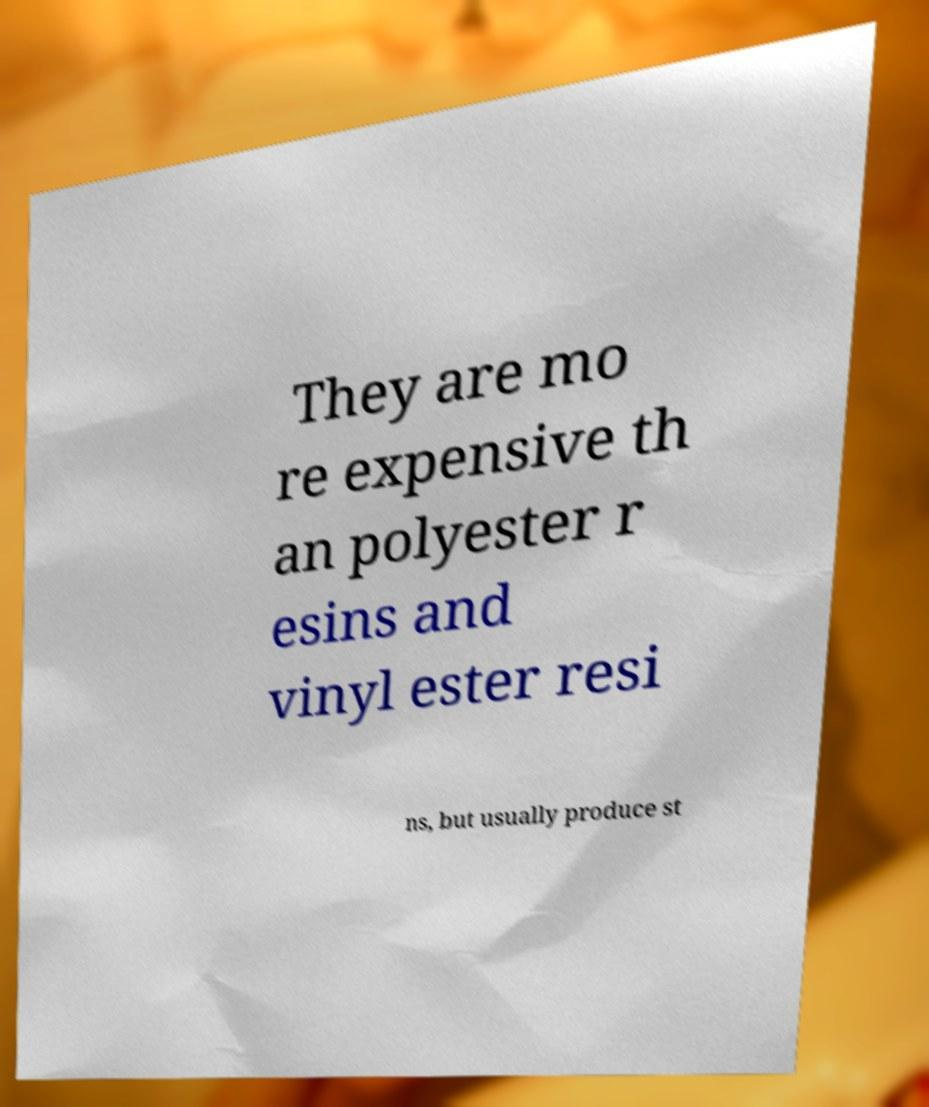Could you extract and type out the text from this image? They are mo re expensive th an polyester r esins and vinyl ester resi ns, but usually produce st 